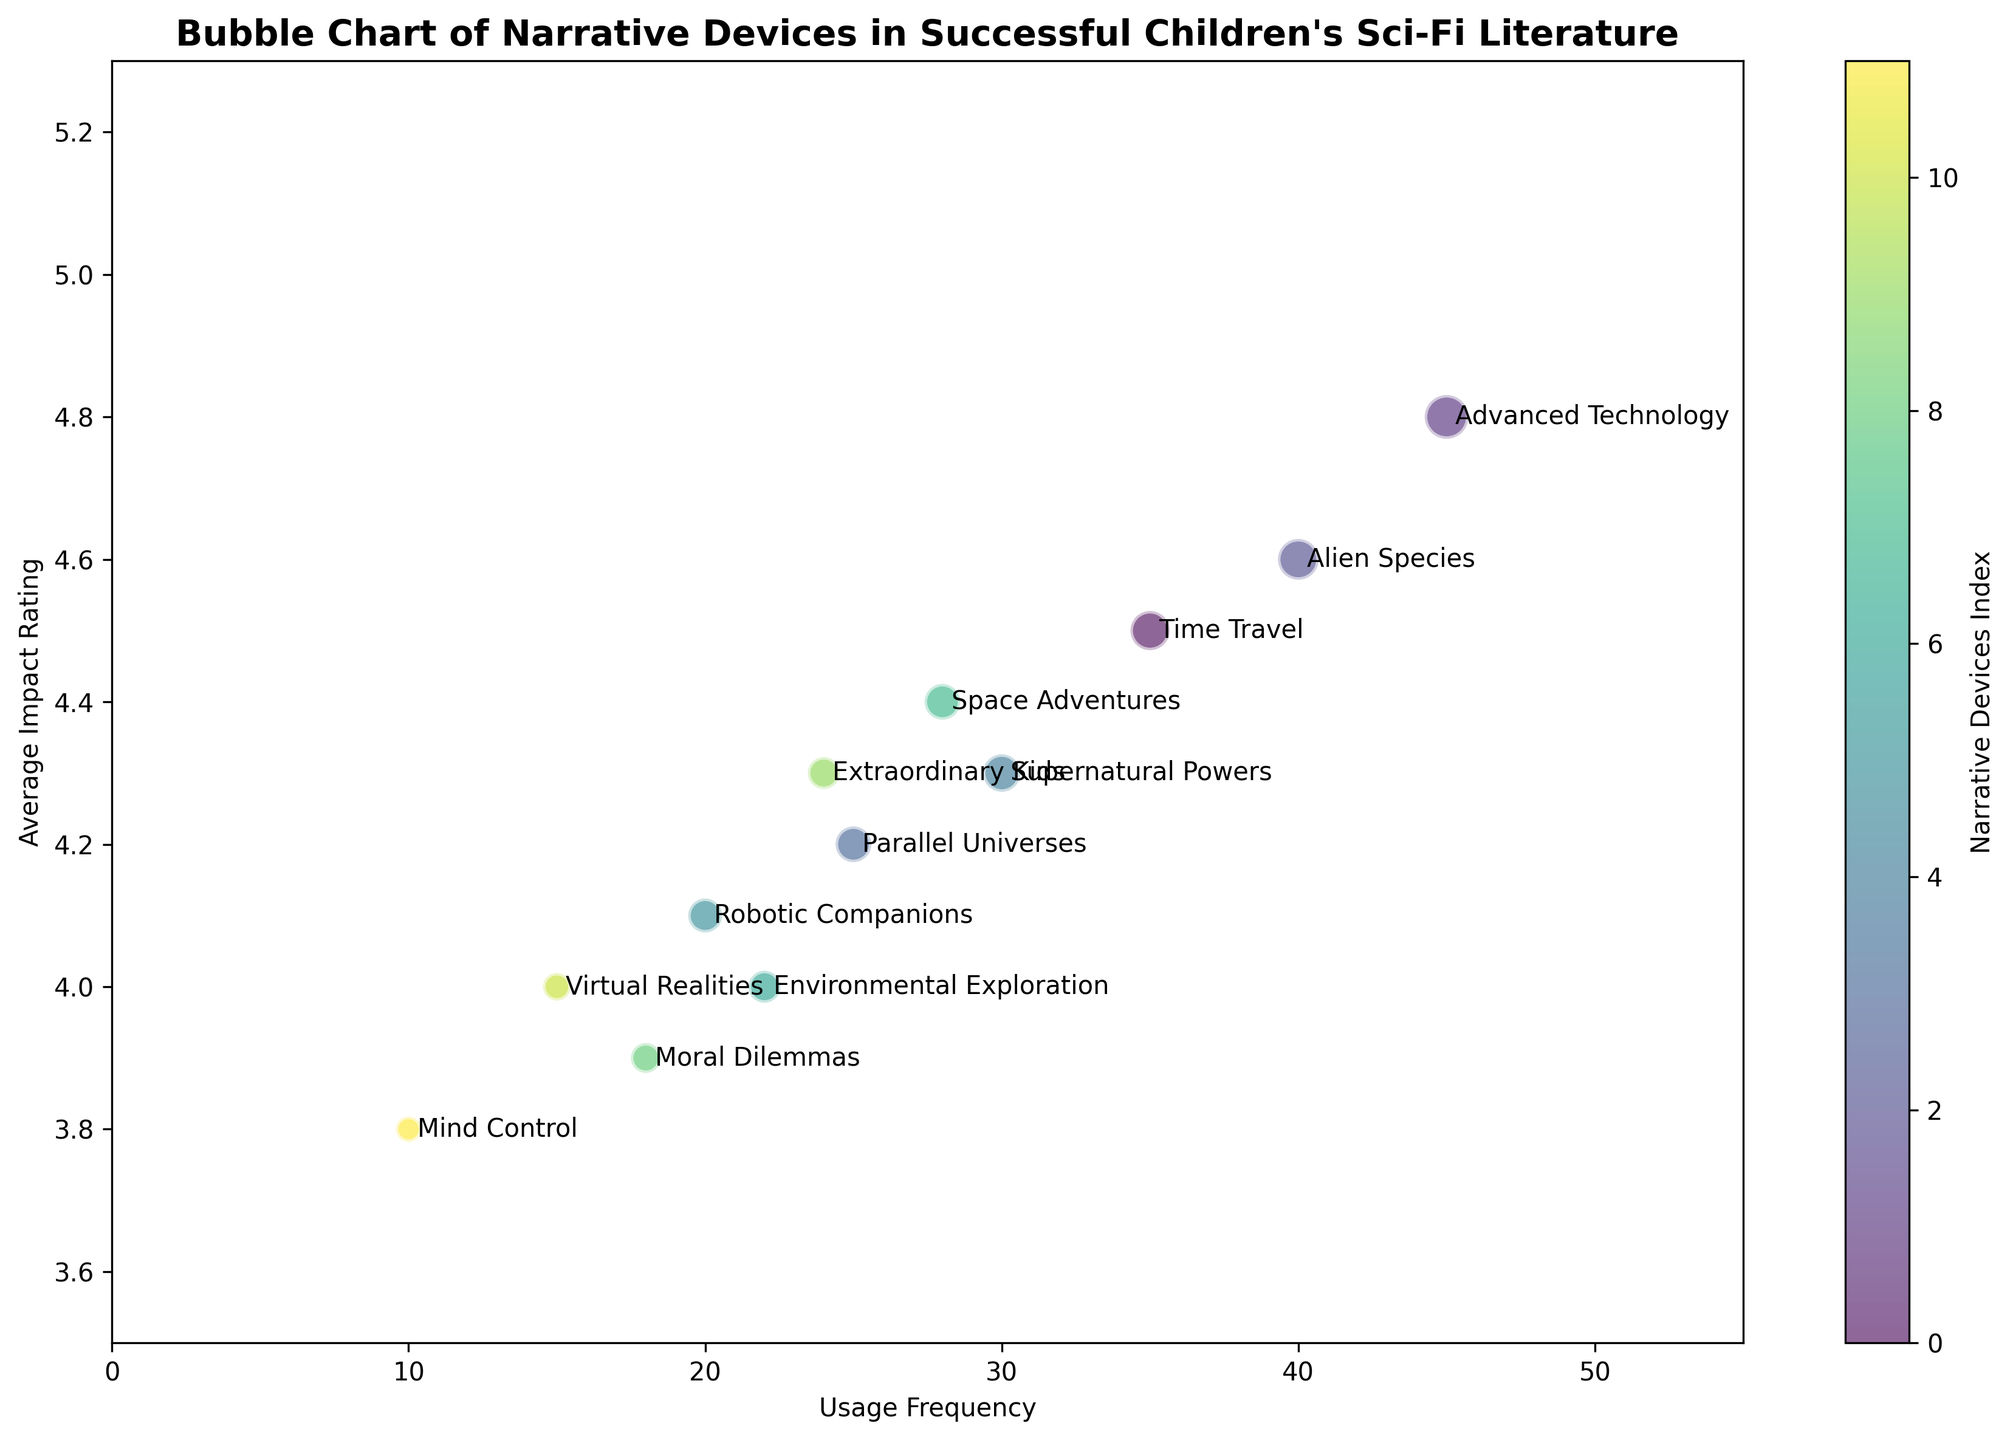What narrative device has the highest usage frequency? Locate the highest point on the x-axis labeled "Usage Frequency". The bubble closest to this point represents "Advanced Technology" with a usage frequency of 45, the largest value for this attribute.
Answer: Advanced Technology Which narrative device has the lowest average impact rating? Identify the lowest point on the y-axis labeled "Average Impact Rating". The corresponding bubble represents "Mind Control" with an average impact rating of 3.8, the lowest value seen.
Answer: Mind Control What is the difference in usage frequency between "Time Travel" and "Space Adventures"? Find the usage frequencies for "Time Travel" (35) and "Space Adventures" (28), and subtract the smaller value from the larger value: 35 - 28.
Answer: 7 How many narrative devices have an average impact rating higher than 4.5? Look at the y-axis to identify bubbles above 4.5. The corresponding narrative devices are "Time Travel", "Advanced Technology", and "Alien Species", totaling 3 narrative devices.
Answer: Three Which narrative device is depicted by the largest bubble, and what does it represent? Identify the largest bubble by visible size, which represents "Advanced Technology". The size correlates with the number of books, which is 15, the highest number.
Answer: Advanced Technology What is the combined number of books for narrative devices with usage frequency less than 20? Locate narrative devices with usage frequencies less than 20 ("Moral Dilemmas", "Virtual Realities", "Mind Control") and sum their book numbers: 7 + 6 + 5 = 18.
Answer: 18 Which narrative device with "Environmental Exploration" as its main attribute has a higher average impact rating than this particular device? "Environmental Exploration" has an average impact rating of 4.0. Look for narrative devices with higher values on the y-axis and compare: "Time Travel", "Advanced Technology", "Alien Species", etc., all have higher ratings.
Answer: Many Compare the number of books between "Parallel Universes" and "Supernatural Powers". Which one has more books and how many more? "Parallel Universes" has 10 books, and "Supernatural Powers" has 11 books. The difference is 11 - 10 = 1. "Supernatural Powers" has more books.
Answer: "Supernatural Powers", 1 Which narrative device located around the middle of the usage frequency and impact rating axes is "Extraordinary Kids", its usage frequency and impact rating coordinates? Find "Extraordinary Kids" near the center of the chart, its coordinates are approximately (24, 4.3).
Answer: (24, 4.3) How many narrative devices fall within the average impact rating range of 4.0 to 4.5 and what are they? Identify bubbles between 4.0 and 4.5 on the y-axis. These are "Supernatural Powers," "Space Adventures," "Environmental Exploration," and "Extraordinary Kids," totaling 4.
Answer: Four: "Supernatural Powers," "Space Adventures," "Environmental Exploration," "Extraordinary Kids" 